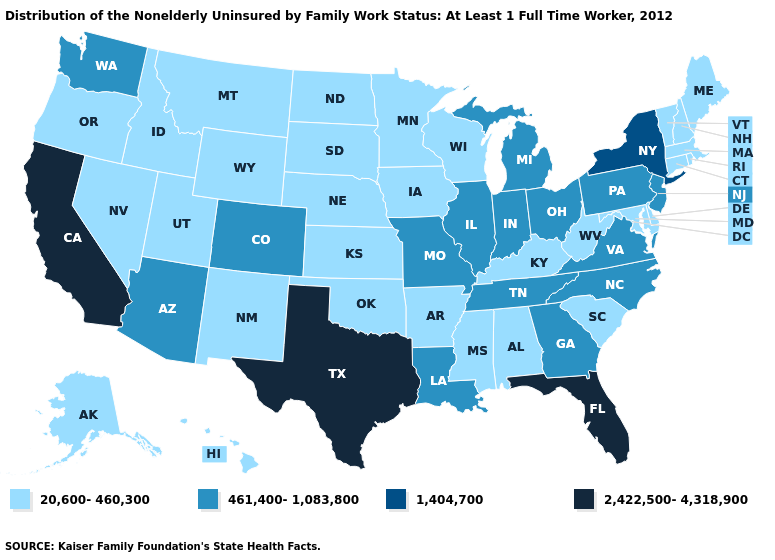How many symbols are there in the legend?
Give a very brief answer. 4. Which states have the lowest value in the South?
Short answer required. Alabama, Arkansas, Delaware, Kentucky, Maryland, Mississippi, Oklahoma, South Carolina, West Virginia. Name the states that have a value in the range 20,600-460,300?
Keep it brief. Alabama, Alaska, Arkansas, Connecticut, Delaware, Hawaii, Idaho, Iowa, Kansas, Kentucky, Maine, Maryland, Massachusetts, Minnesota, Mississippi, Montana, Nebraska, Nevada, New Hampshire, New Mexico, North Dakota, Oklahoma, Oregon, Rhode Island, South Carolina, South Dakota, Utah, Vermont, West Virginia, Wisconsin, Wyoming. Name the states that have a value in the range 20,600-460,300?
Short answer required. Alabama, Alaska, Arkansas, Connecticut, Delaware, Hawaii, Idaho, Iowa, Kansas, Kentucky, Maine, Maryland, Massachusetts, Minnesota, Mississippi, Montana, Nebraska, Nevada, New Hampshire, New Mexico, North Dakota, Oklahoma, Oregon, Rhode Island, South Carolina, South Dakota, Utah, Vermont, West Virginia, Wisconsin, Wyoming. Name the states that have a value in the range 1,404,700?
Keep it brief. New York. How many symbols are there in the legend?
Answer briefly. 4. Which states have the highest value in the USA?
Answer briefly. California, Florida, Texas. Does the map have missing data?
Concise answer only. No. Does Tennessee have the highest value in the USA?
Write a very short answer. No. Name the states that have a value in the range 1,404,700?
Give a very brief answer. New York. What is the lowest value in the South?
Keep it brief. 20,600-460,300. Does the first symbol in the legend represent the smallest category?
Quick response, please. Yes. What is the value of Nevada?
Quick response, please. 20,600-460,300. How many symbols are there in the legend?
Concise answer only. 4. What is the value of Wisconsin?
Quick response, please. 20,600-460,300. 